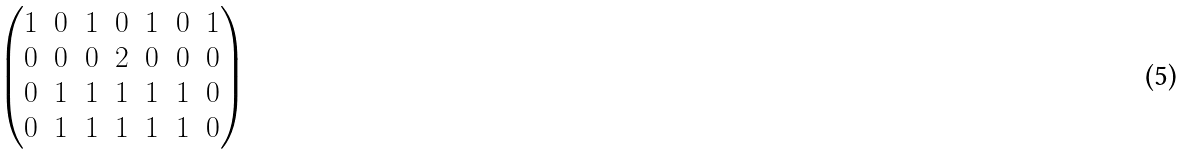<formula> <loc_0><loc_0><loc_500><loc_500>\begin{pmatrix} 1 & 0 & 1 & 0 & 1 & 0 & 1 \\ 0 & 0 & 0 & 2 & 0 & 0 & 0 \\ 0 & 1 & 1 & 1 & 1 & 1 & 0 \\ 0 & 1 & 1 & 1 & 1 & 1 & 0 \end{pmatrix}</formula> 